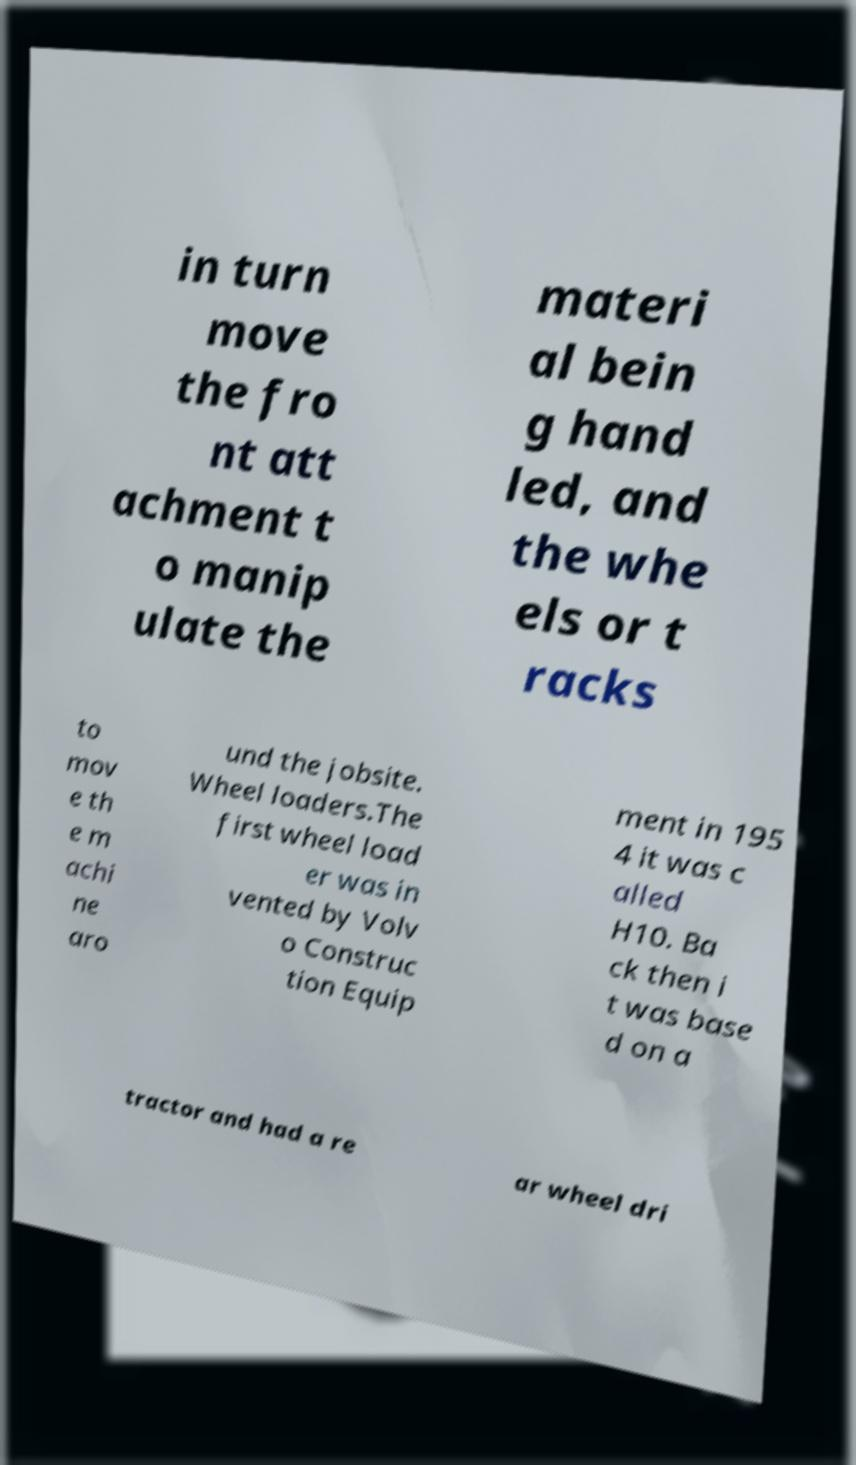For documentation purposes, I need the text within this image transcribed. Could you provide that? in turn move the fro nt att achment t o manip ulate the materi al bein g hand led, and the whe els or t racks to mov e th e m achi ne aro und the jobsite. Wheel loaders.The first wheel load er was in vented by Volv o Construc tion Equip ment in 195 4 it was c alled H10. Ba ck then i t was base d on a tractor and had a re ar wheel dri 